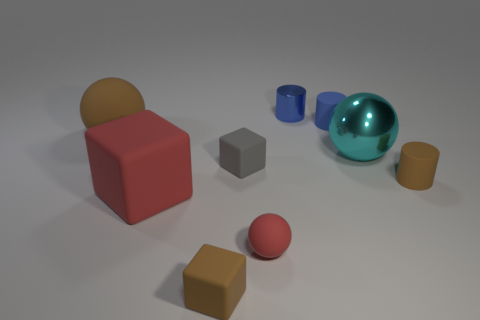How many balls are behind the large thing right of the large red block?
Your answer should be compact. 1. Does the blue metallic object have the same shape as the tiny red thing?
Your response must be concise. No. Is there anything else that is the same color as the big shiny sphere?
Keep it short and to the point. No. Is the shape of the cyan object the same as the large matte object behind the tiny brown rubber cylinder?
Provide a succinct answer. Yes. The object behind the small matte cylinder that is behind the brown rubber thing that is right of the tiny red rubber object is what color?
Your answer should be compact. Blue. There is a small matte object that is on the right side of the shiny ball; does it have the same shape as the blue metal object?
Provide a succinct answer. Yes. What is the material of the tiny red sphere?
Give a very brief answer. Rubber. There is a rubber object that is behind the large sphere that is on the left side of the metallic object behind the tiny blue matte object; what is its shape?
Your answer should be compact. Cylinder. How many other objects are the same shape as the small red rubber object?
Give a very brief answer. 2. Do the large block and the sphere that is in front of the big red matte object have the same color?
Keep it short and to the point. Yes. 